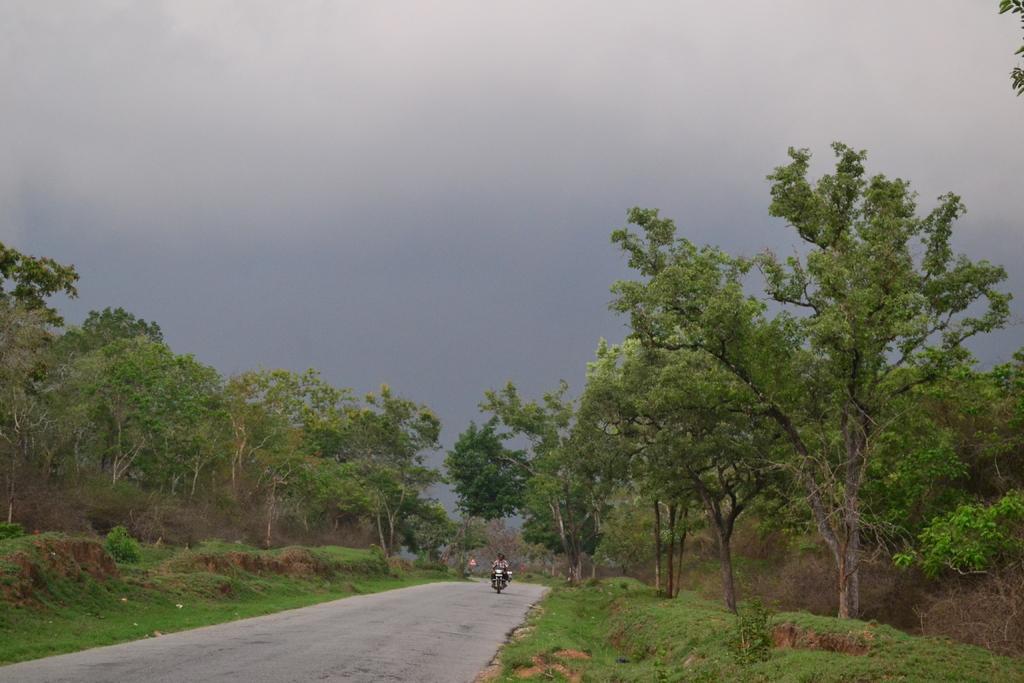Describe this image in one or two sentences. On the left side, there is a person riding a bike on the road. On the right side, there are trees, plants and grass on the ground. In the background, there are trees, plants and grass on the ground and there are clouds in the sky. 